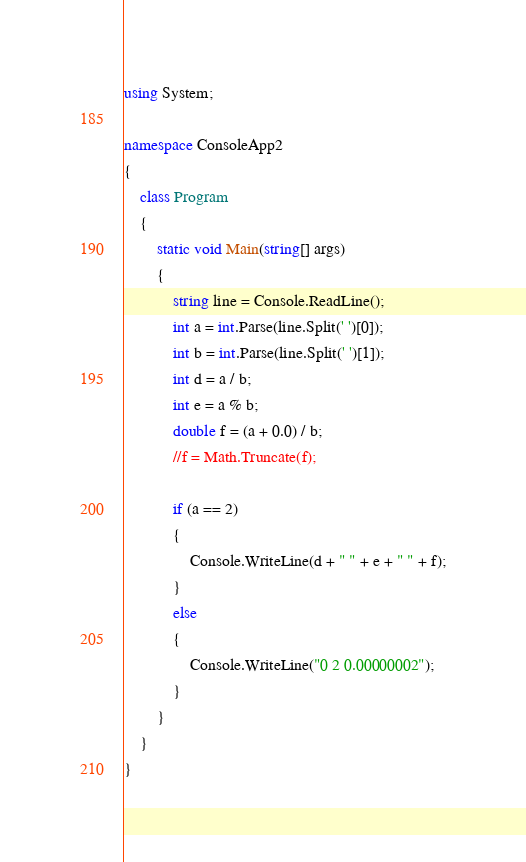<code> <loc_0><loc_0><loc_500><loc_500><_C#_>using System;

namespace ConsoleApp2
{
    class Program
    {
        static void Main(string[] args)
        {
            string line = Console.ReadLine();
            int a = int.Parse(line.Split(' ')[0]);
            int b = int.Parse(line.Split(' ')[1]);
            int d = a / b;
            int e = a % b;
            double f = (a + 0.0) / b;
            //f = Math.Truncate(f);

            if (a == 2)
            {
                Console.WriteLine(d + " " + e + " " + f);
            }
            else
            {
                Console.WriteLine("0 2 0.00000002");
            }
        }
    }
}

</code> 